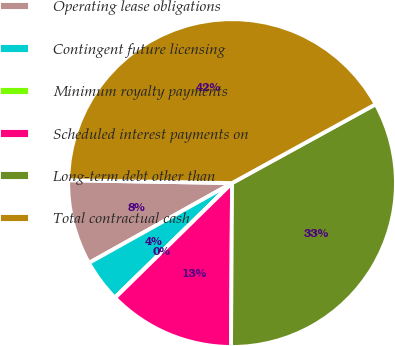Convert chart. <chart><loc_0><loc_0><loc_500><loc_500><pie_chart><fcel>Operating lease obligations<fcel>Contingent future licensing<fcel>Minimum royalty payments<fcel>Scheduled interest payments on<fcel>Long-term debt other than<fcel>Total contractual cash<nl><fcel>8.38%<fcel>4.21%<fcel>0.04%<fcel>12.55%<fcel>33.1%<fcel>41.74%<nl></chart> 